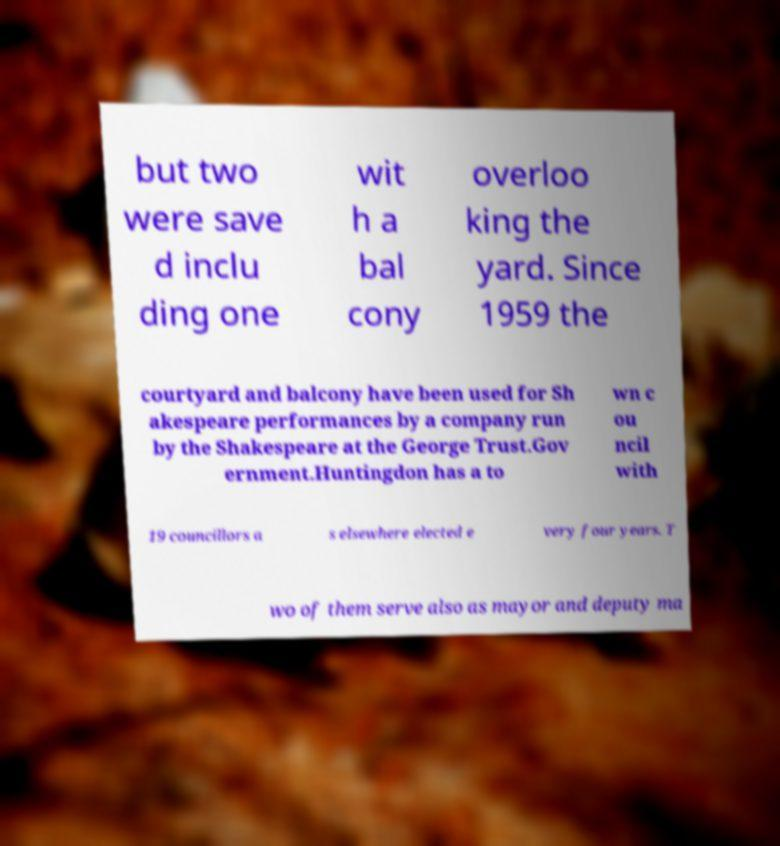I need the written content from this picture converted into text. Can you do that? but two were save d inclu ding one wit h a bal cony overloo king the yard. Since 1959 the courtyard and balcony have been used for Sh akespeare performances by a company run by the Shakespeare at the George Trust.Gov ernment.Huntingdon has a to wn c ou ncil with 19 councillors a s elsewhere elected e very four years. T wo of them serve also as mayor and deputy ma 